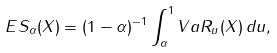Convert formula to latex. <formula><loc_0><loc_0><loc_500><loc_500>E S _ { \alpha } ( X ) = ( 1 - \alpha ) ^ { - 1 } \int _ { \alpha } ^ { 1 } V a R _ { u } ( X ) \, d u ,</formula> 